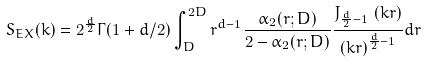<formula> <loc_0><loc_0><loc_500><loc_500>S _ { E X } ( k ) = 2 ^ { \frac { d } { 2 } } \Gamma ( 1 + d / 2 ) \int _ { D } ^ { 2 D } r ^ { d - 1 } \frac { \alpha _ { 2 } ( r ; D ) } { 2 - \alpha _ { 2 } ( r ; D ) } \frac { J _ { \frac { d } { 2 } - 1 } \, \left ( k r \right ) } { \left ( k r \right ) ^ { \frac { d } { 2 } - 1 } } d r</formula> 